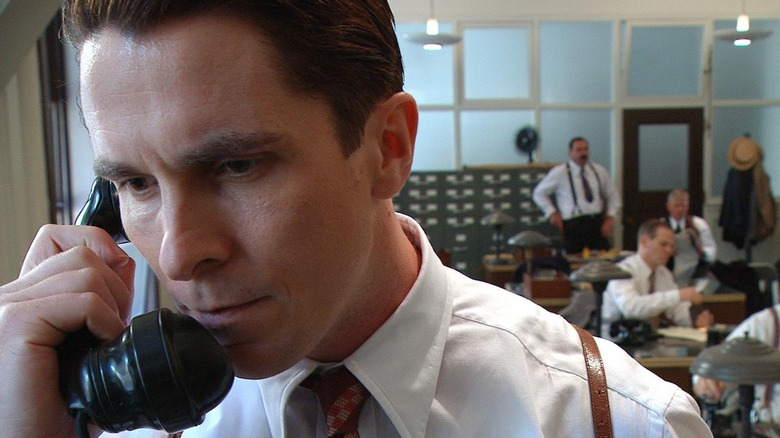Can you describe the atmosphere in the room? The atmosphere in the room appears to be quite serious and focused. The blue-painted walls add a calm yet professional tone to the setting. The men in the background, one sitting at a desk working on paperwork and another standing near a hat rack, contribute to the bustling office environment. The lighting is soft and natural, casting light on the men, and creating an ambiance of deep concentration and activity. Why is Alfred Borden so deep in thought on the phone? Alfred Borden's deep concentration as he speaks on the phone suggests he is engaged in a critical conversation. This likely involves important business or perhaps a personal matter that requires his undivided attention. Borden's body language and facial expression indicate the gravity of the situation, emphasizing his need to focus intensely on the call without distraction, reflective of the serious tone depicted in the scene. Imagine this office has a secret hidden door. Where would it be and what could it lead to? If this office had a secret hidden door, it might be seamlessly integrated into the wall behind the hat rack. The door could be camouflaged as a bookshelf or a filing cabinet that swings open when a specific book is pulled or a hidden lever is triggered. Upon opening, it could reveal a narrow, dimly-lit staircase leading down to a secret underground chamber. This chamber might be equipped with intricate machinery related to the tricks and illusions employed by magicians in 'The Prestige,' serving as a clandestine workshop or a safe haven for brainstorming and constructing new magic tricks. It could also house sensitive documents or items integral to the plot of the movie, guarded against any prying eyes. Can you create a realistic scenario that might be happening in the background of this scene? In the background of this scene, one possible scenario is that the man sitting at the desk is meticulously reviewing financial records related to the performances of the magic acts. Meanwhile, the man standing near the hat rack could be engaged in a discussion with another colleague about upcoming shows and logistical arrangements. The atmosphere is tense as they try to ensure everything runs smoothly for the next big magic performance, reflecting the high stakes and intricate planning involved in their work. This realistic scenario adds to the overall busy and concentrated environment of the room. Can you create another detailed description of a scenario that involves one of the background characters? Sure! The man sitting at the desk with stacks of paper scattered around appears to be the accountant for the magic troupe. He’s meticulously balancing the books, making sure all expenses and incomes are accounted for after a busy month of performances. He jots down notes, occasionally referencing a ledger, as beads of sweat form on his forehead, a sign of the mounting pressure to ensure financial accuracy. Across the room, the man standing by the hat rack might be the stage manager, deep in conversation with a magician’s assistant about the next big illusion. They’re discussing critical details -- from the timing of the act, the setup of the stage, to the safety protocols. This discussion is pivotal to ensure the flawless execution of the upcoming performance, highlighting the immense teamwork and coordination that takes place behind the scenes. 